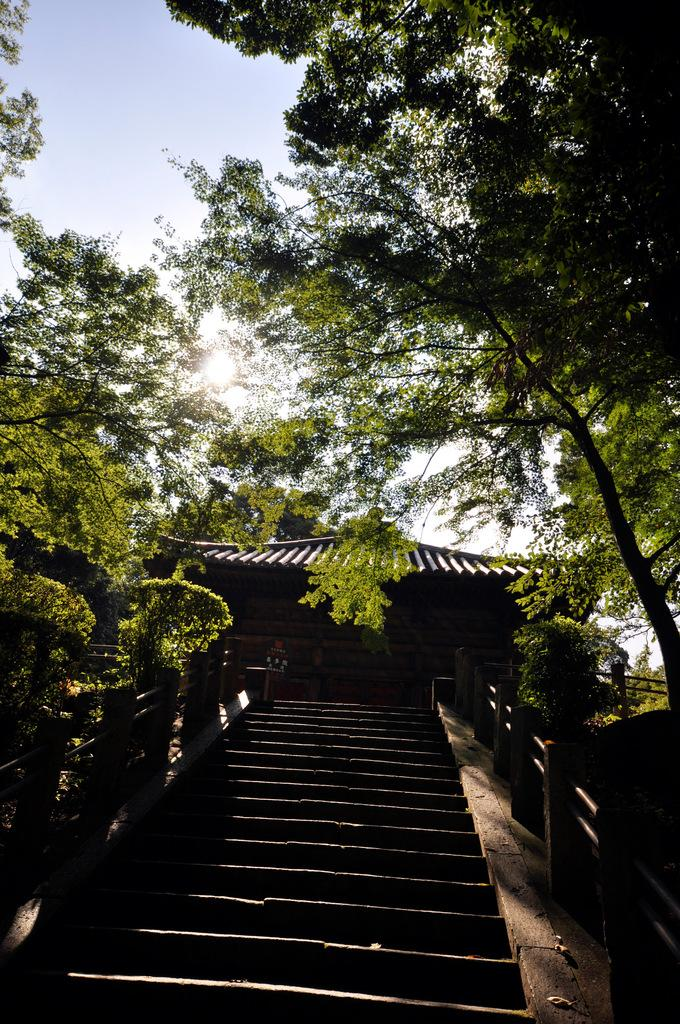What type of architectural feature can be seen in the image? There are steps in the image. What structure is located near the steps? There is a house in the image. What type of natural elements are present in the image? There are trees in the image. What celestial body is visible in the image? The sun is visible in the image. What can be seen in the background of the image? The sky is visible in the background of the image. What type of plate is being used to catch the sun's rays in the image? There is no plate present in the image, and the sun's rays are not being caught by any object. 